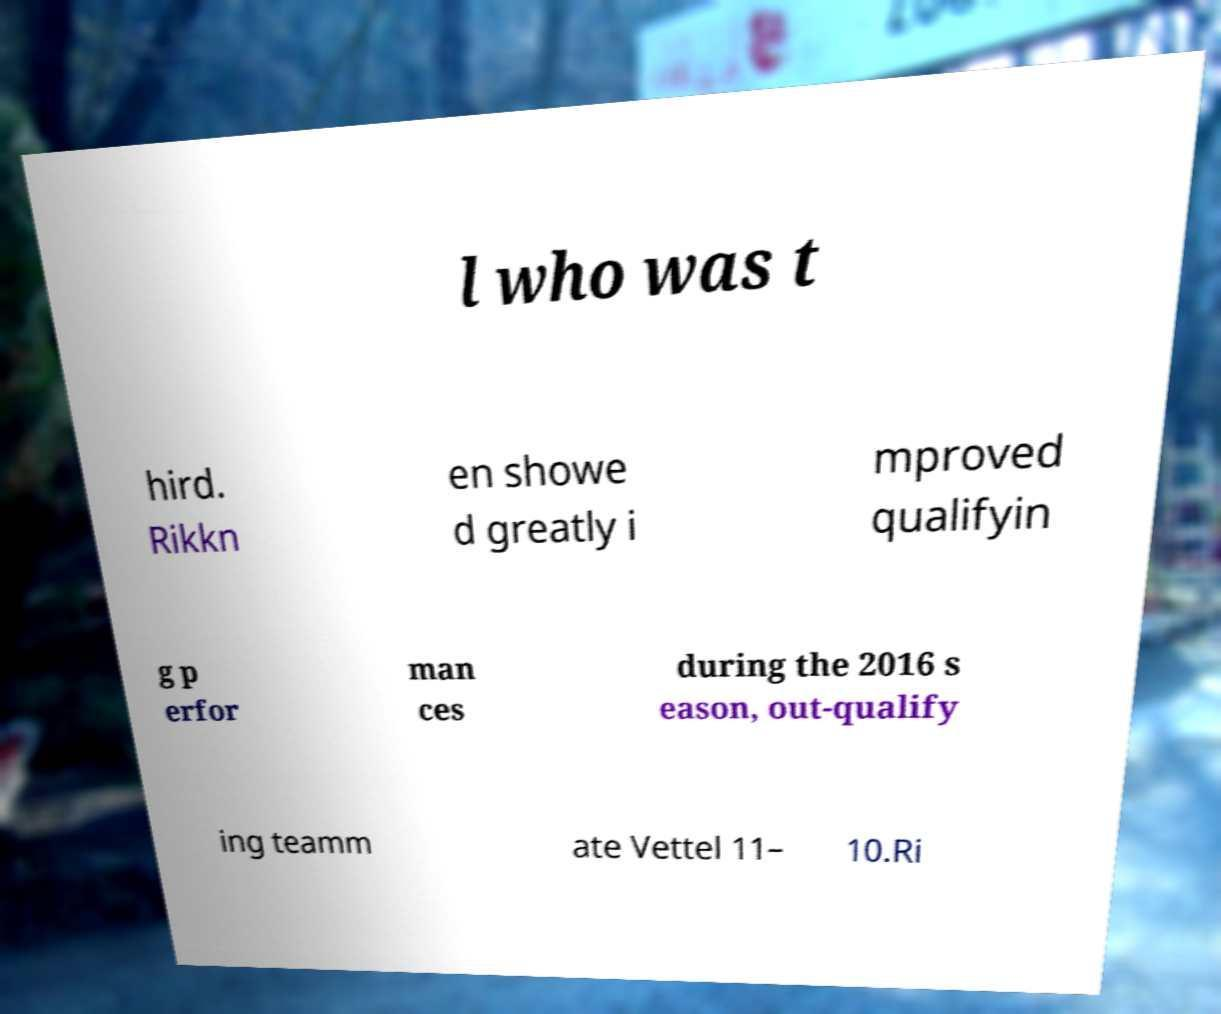Can you accurately transcribe the text from the provided image for me? l who was t hird. Rikkn en showe d greatly i mproved qualifyin g p erfor man ces during the 2016 s eason, out-qualify ing teamm ate Vettel 11– 10.Ri 